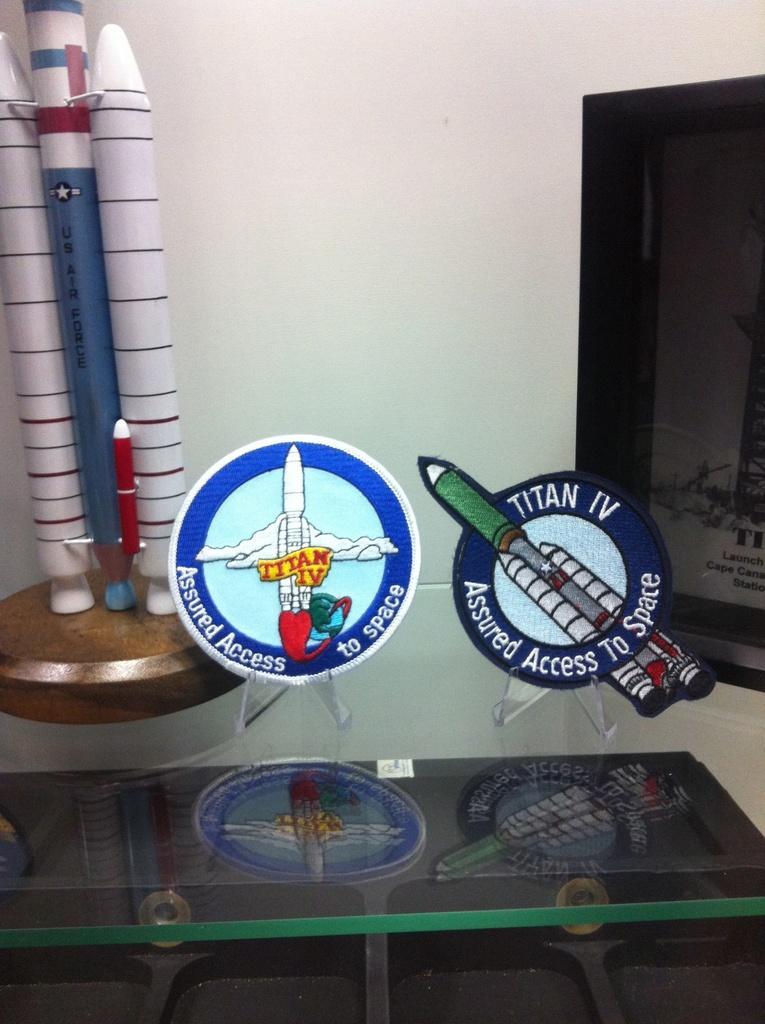Describe this image in one or two sentences. This image is taken indoors. In the background there is a wall. In the middle of the image there are a few show pieces with a text on the glass table. 